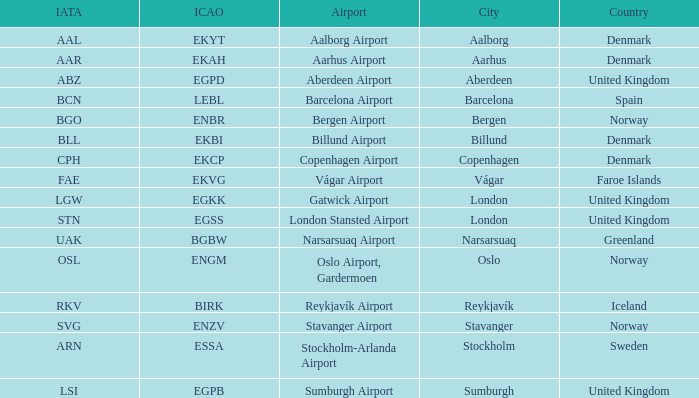What is the ICAO for Denmark, and the IATA is bll? EKBI. 